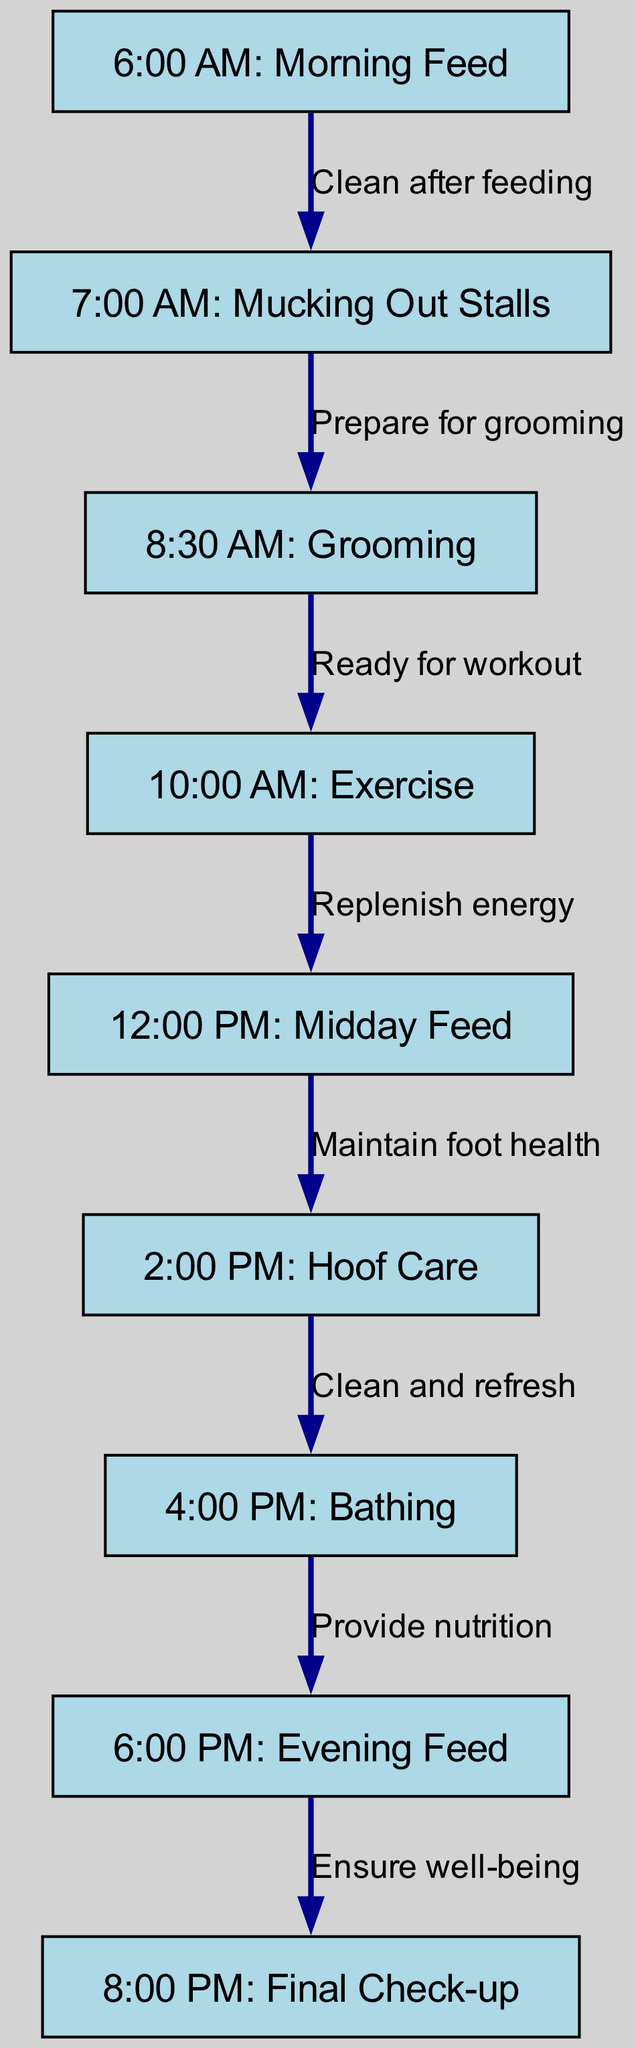What is the first task in the daily routine? The diagram lists the first task as "6:00 AM: Morning Feed" in the node sequence.
Answer: Morning Feed How many total tasks are shown in the diagram? By counting the nodes in the diagram, there are 9 tasks listed involving various aspects of racehorse care.
Answer: 9 What follows the "8:30 AM: Grooming" task? According to the flow of the diagram, the task that follows "8:30 AM: Grooming" is "10:00 AM: Exercise", as indicated by the connecting edge.
Answer: Exercise What task is associated with hoof care? The diagram specifies that "2:00 PM: Hoof Care" is the task dedicated to maintaining the hoof health of racehorses.
Answer: Hoof Care Which task is the last in the daily routine? The final task in the series as per the diagram is "8:00 PM: Final Check-up", which is denoted as the last node.
Answer: Final Check-up What is the relationship between "6:00 PM: Evening Feed" and "8:00 PM: Final Check-up"? The edge connecting these two tasks shows that the purpose of the evening feed is to "Ensure well-being" before the final check-up.
Answer: Ensure well-being What time is allocated for bathing the horses? The diagram indicates that "4:00 PM: Bathing" is the designated time for bathing the horses during the daily care routine.
Answer: 4:00 PM What is the last action taken after the evening feed? The last action indicated in the diagram after the evening feed is "8:00 PM: Final Check-up" which ensures the well-being of the horses.
Answer: Final Check-up 